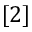<formula> <loc_0><loc_0><loc_500><loc_500>[ 2 ]</formula> 